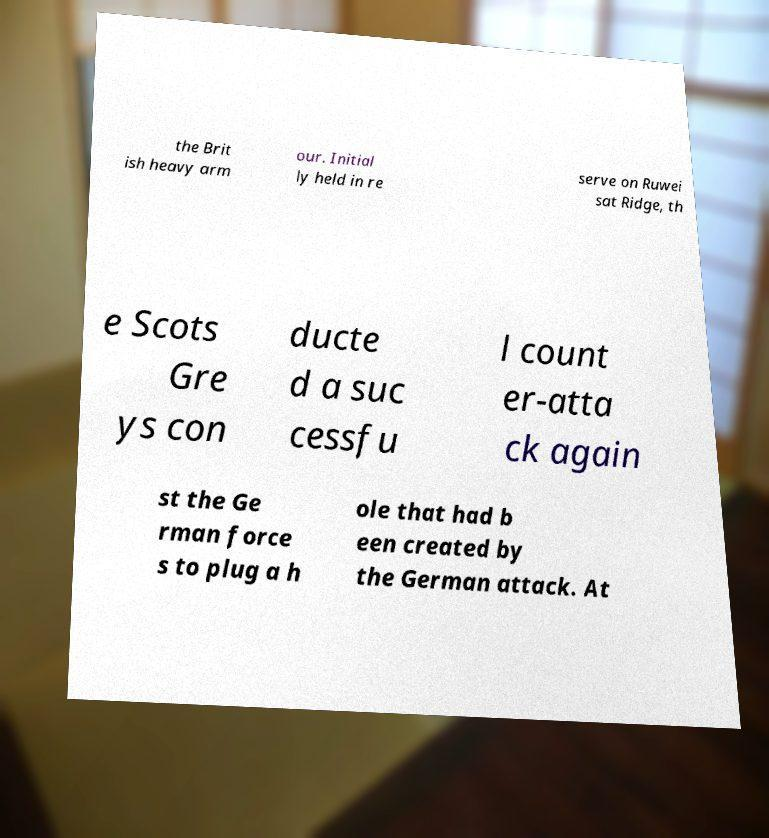Can you read and provide the text displayed in the image?This photo seems to have some interesting text. Can you extract and type it out for me? the Brit ish heavy arm our. Initial ly held in re serve on Ruwei sat Ridge, th e Scots Gre ys con ducte d a suc cessfu l count er-atta ck again st the Ge rman force s to plug a h ole that had b een created by the German attack. At 